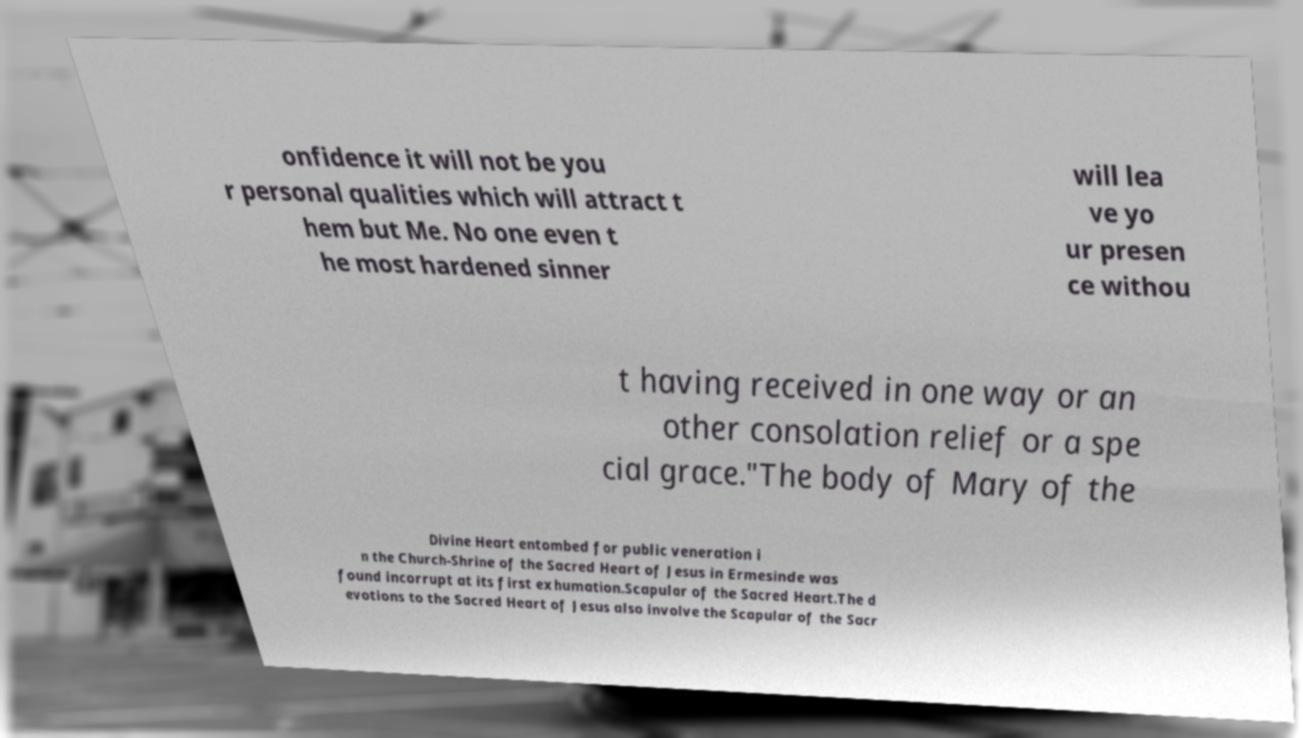Could you assist in decoding the text presented in this image and type it out clearly? onfidence it will not be you r personal qualities which will attract t hem but Me. No one even t he most hardened sinner will lea ve yo ur presen ce withou t having received in one way or an other consolation relief or a spe cial grace."The body of Mary of the Divine Heart entombed for public veneration i n the Church-Shrine of the Sacred Heart of Jesus in Ermesinde was found incorrupt at its first exhumation.Scapular of the Sacred Heart.The d evotions to the Sacred Heart of Jesus also involve the Scapular of the Sacr 